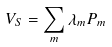<formula> <loc_0><loc_0><loc_500><loc_500>V _ { S } = \sum _ { m } \lambda _ { m } P _ { m }</formula> 